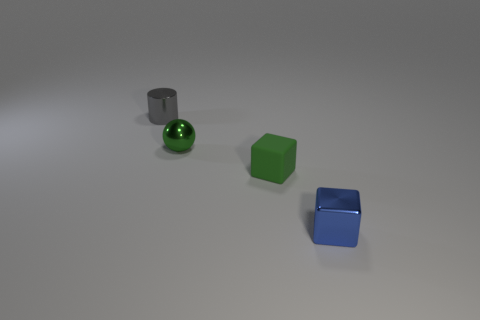What is the shape of the object that is the same color as the small sphere?
Offer a terse response. Cube. What color is the metallic thing that is both behind the small blue cube and on the right side of the gray shiny cylinder?
Your answer should be very brief. Green. What number of small green objects are left of the small shiny thing to the left of the tiny green metal ball?
Your answer should be very brief. 0. Does the small gray object have the same shape as the rubber thing?
Offer a terse response. No. Is there any other thing that is the same color as the cylinder?
Offer a terse response. No. There is a blue metal object; does it have the same shape as the small object left of the small green sphere?
Provide a short and direct response. No. There is a cube to the right of the small block that is behind the small metallic object in front of the small rubber block; what color is it?
Your response must be concise. Blue. Is there anything else that has the same material as the small green ball?
Offer a terse response. Yes. There is a tiny shiny thing behind the small green sphere; is it the same shape as the tiny blue thing?
Keep it short and to the point. No. What is the material of the gray cylinder?
Make the answer very short. Metal. 